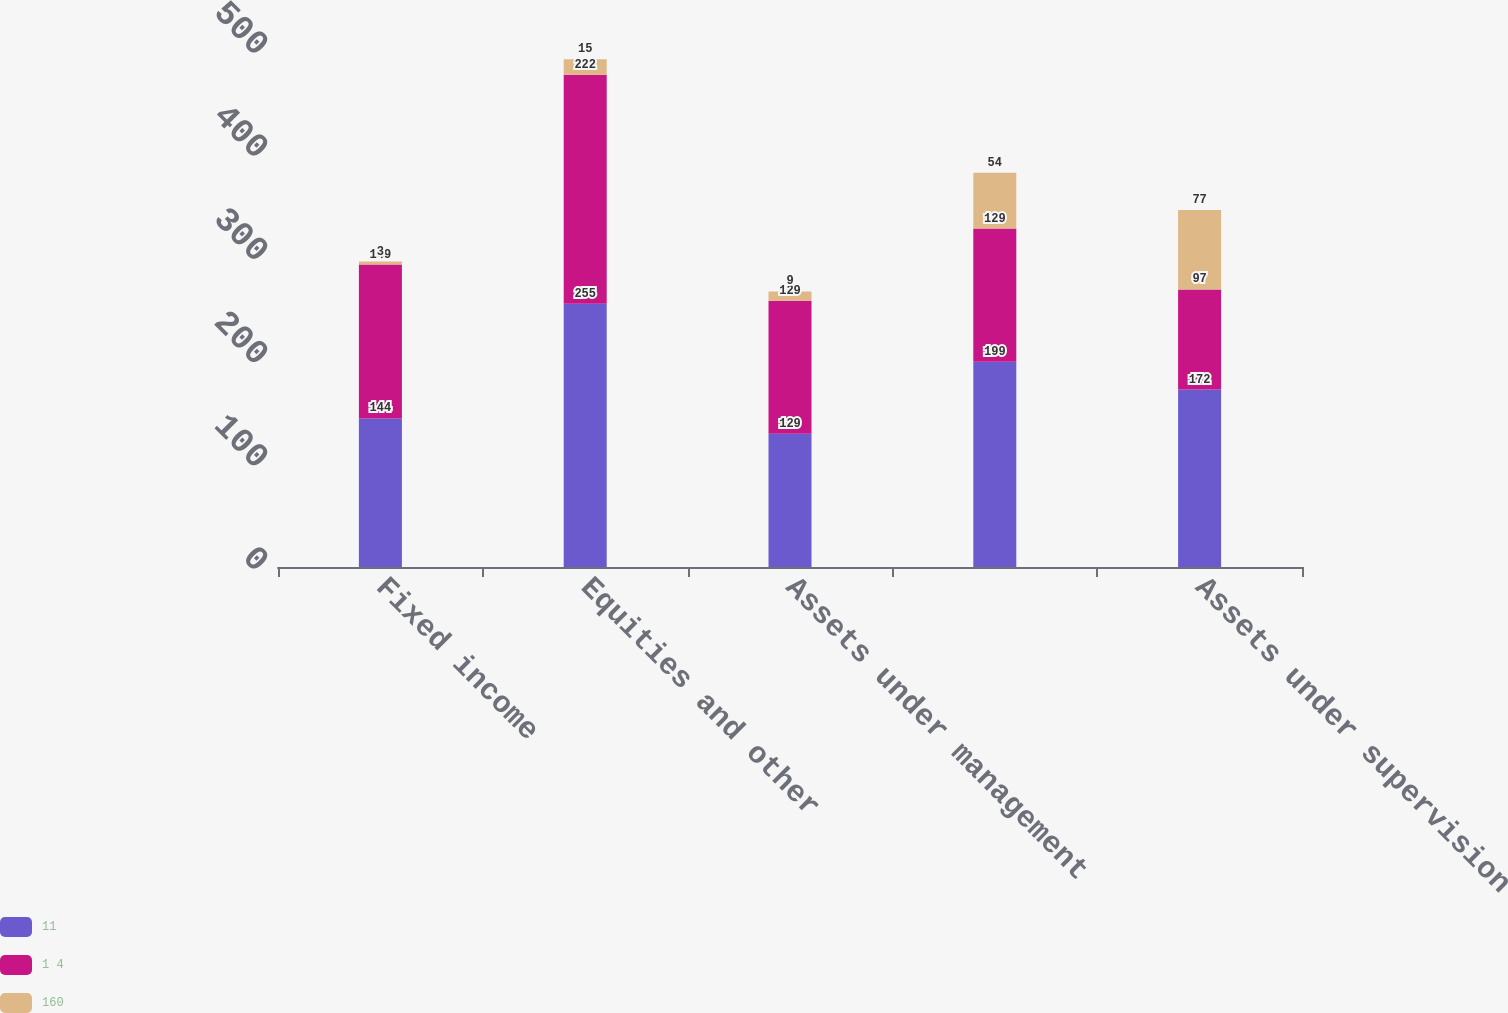<chart> <loc_0><loc_0><loc_500><loc_500><stacked_bar_chart><ecel><fcel>Fixed income<fcel>Equities and other<fcel>Assets under management<fcel>Unnamed: 4<fcel>Assets under supervision<nl><fcel>11<fcel>144<fcel>255<fcel>129<fcel>199<fcel>172<nl><fcel>1 4<fcel>149<fcel>222<fcel>129<fcel>129<fcel>97<nl><fcel>160<fcel>3<fcel>15<fcel>9<fcel>54<fcel>77<nl></chart> 